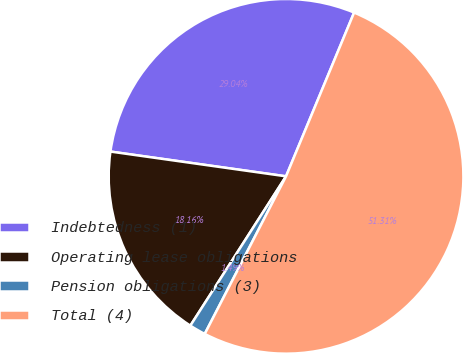Convert chart to OTSL. <chart><loc_0><loc_0><loc_500><loc_500><pie_chart><fcel>Indebtedness (1)<fcel>Operating lease obligations<fcel>Pension obligations (3)<fcel>Total (4)<nl><fcel>29.04%<fcel>18.16%<fcel>1.49%<fcel>51.31%<nl></chart> 